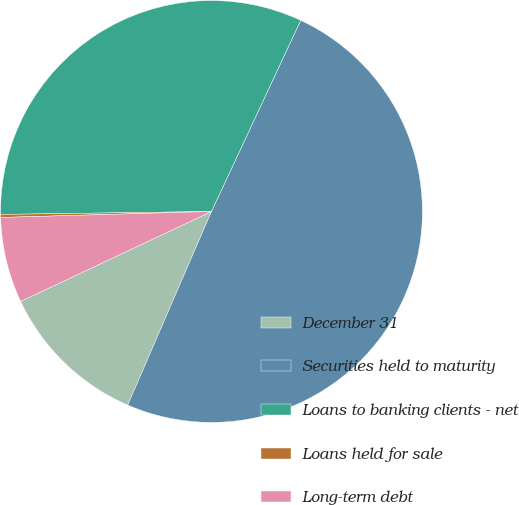<chart> <loc_0><loc_0><loc_500><loc_500><pie_chart><fcel>December 31<fcel>Securities held to maturity<fcel>Loans to banking clients - net<fcel>Loans held for sale<fcel>Long-term debt<nl><fcel>11.49%<fcel>49.54%<fcel>32.17%<fcel>0.23%<fcel>6.56%<nl></chart> 